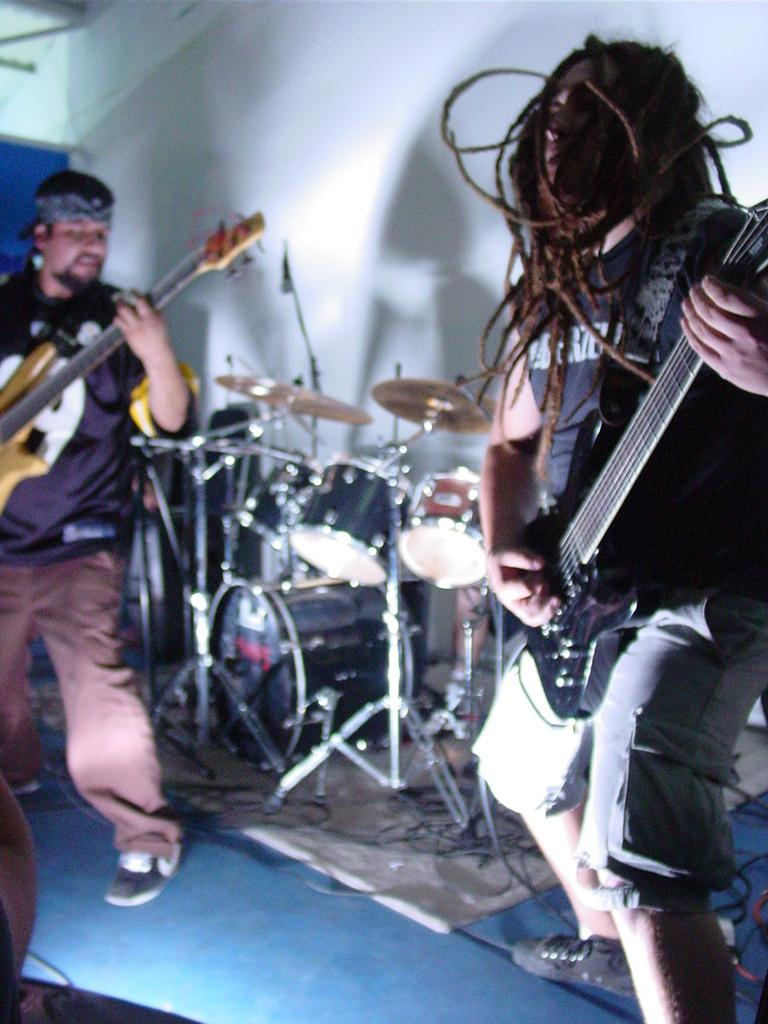What can be seen in the background of the image? There is a wall in the background of the image. How many people are in the image? There are two persons in the image. What are the two persons doing? The two persons are playing guitars. What other musical instruments are present in the image? There are drums and cymbals in the image. Where does the scene take place? The scene takes place on a platform. What is the size of the paste used by the musicians in the image? There is no paste present in the image; the musicians are playing guitars, drums, and cymbals. What school do the musicians in the image attend? There is no information about a school or any educational context in the image. 